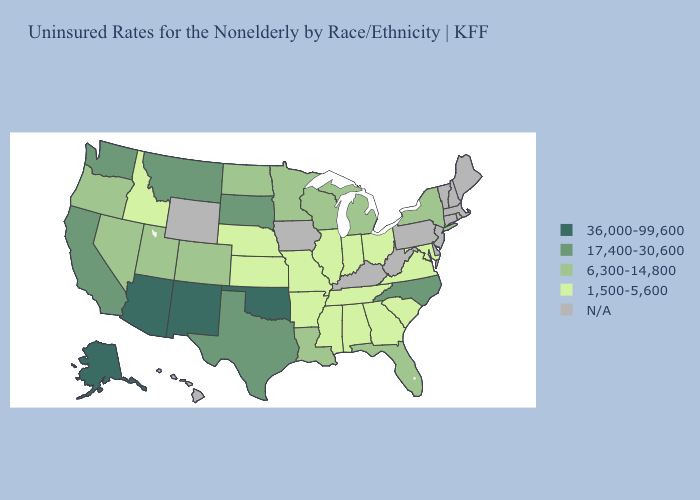What is the highest value in the South ?
Concise answer only. 36,000-99,600. Does California have the highest value in the USA?
Concise answer only. No. What is the value of Vermont?
Quick response, please. N/A. What is the value of Alabama?
Write a very short answer. 1,500-5,600. Among the states that border Virginia , which have the lowest value?
Be succinct. Maryland, Tennessee. Name the states that have a value in the range 36,000-99,600?
Give a very brief answer. Alaska, Arizona, New Mexico, Oklahoma. What is the highest value in the USA?
Write a very short answer. 36,000-99,600. What is the lowest value in states that border Illinois?
Short answer required. 1,500-5,600. What is the lowest value in the MidWest?
Short answer required. 1,500-5,600. Does Idaho have the lowest value in the West?
Give a very brief answer. Yes. What is the value of South Carolina?
Give a very brief answer. 1,500-5,600. Among the states that border New Jersey , which have the lowest value?
Be succinct. New York. 